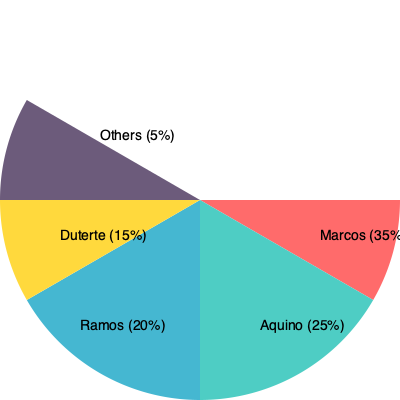Based on the pie chart showing the distribution of government projects in Mindanao under various presidencies, which administration allocated the highest percentage of projects to the region, and how does this compare to the combined allocation of the two least-contributing administrations shown? To answer this question, we need to analyze the pie chart and perform some calculations:

1. Identify the highest percentage:
   The Marcos administration has the largest slice at 35%.

2. Identify the two least-contributing administrations:
   Duterte administration: 15%
   Others: 5%

3. Calculate the combined allocation of the two least-contributing administrations:
   $15\% + 5\% = 20\%$

4. Compare the highest percentage to the combined allocation:
   Marcos administration: 35%
   Two least-contributing combined: 20%
   
   Difference: $35\% - 20\% = 15\%$

5. Express the comparison:
   The Marcos administration's allocation (35%) is 15 percentage points higher than the combined allocation of the two least-contributing administrations (20%).

This analysis shows that the Marcos administration significantly outperformed the bottom two administrations combined in terms of project allocation to Mindanao.
Answer: Marcos; 15 percentage points higher than bottom two combined. 